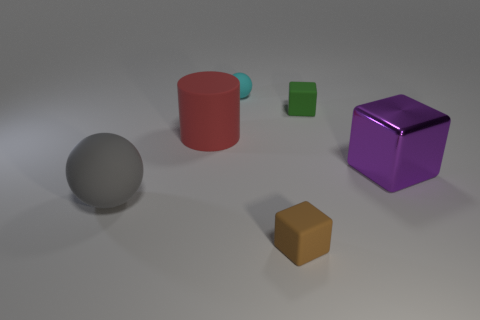There is another large object that is the same shape as the green rubber thing; what material is it?
Provide a short and direct response. Metal. What is the material of the big object that is right of the tiny brown object?
Your response must be concise. Metal. There is a small ball that is made of the same material as the big cylinder; what color is it?
Keep it short and to the point. Cyan. How many brown rubber things have the same size as the brown block?
Your answer should be very brief. 0. There is a rubber sphere behind the green block; does it have the same size as the gray object?
Offer a very short reply. No. What is the shape of the matte thing that is right of the big gray rubber sphere and in front of the purple thing?
Your answer should be very brief. Cube. There is a cyan ball; are there any red objects left of it?
Ensure brevity in your answer.  Yes. Is there anything else that is the same shape as the large red matte thing?
Offer a very short reply. No. Is the brown matte thing the same shape as the purple object?
Your response must be concise. Yes. Are there an equal number of gray rubber objects to the right of the small cyan thing and small brown matte objects that are to the left of the red cylinder?
Offer a very short reply. Yes. 